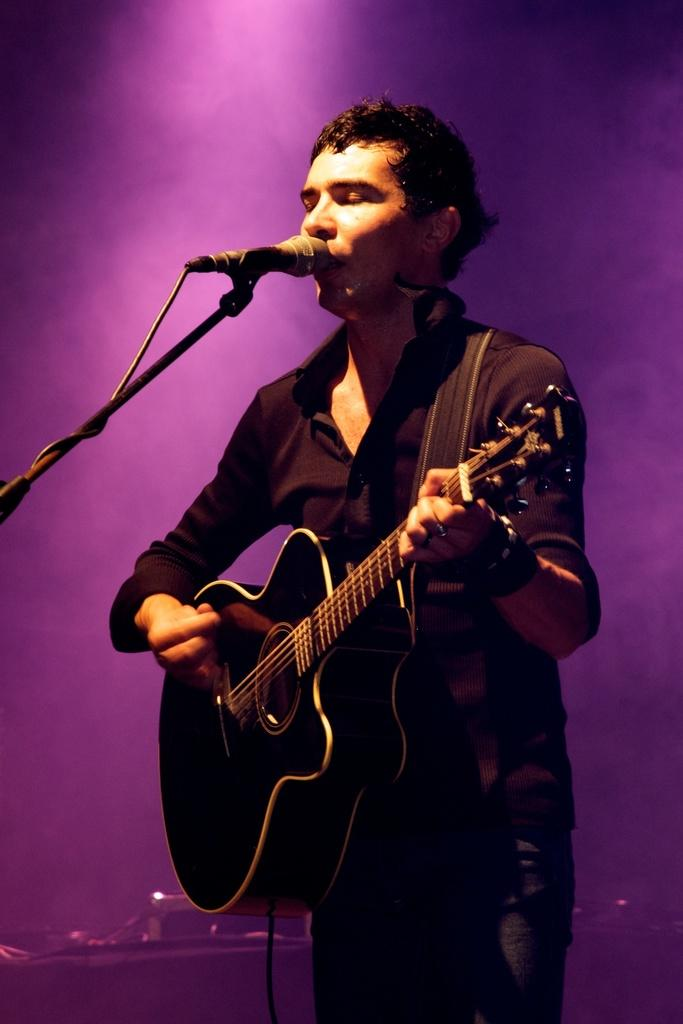What is the person in the image doing? The person is playing a guitar and singing. What object is in front of the person? There is a microphone in front of the person. How does the person grip the roll in the image? There is no roll present in the image; the person is playing a guitar and singing. 